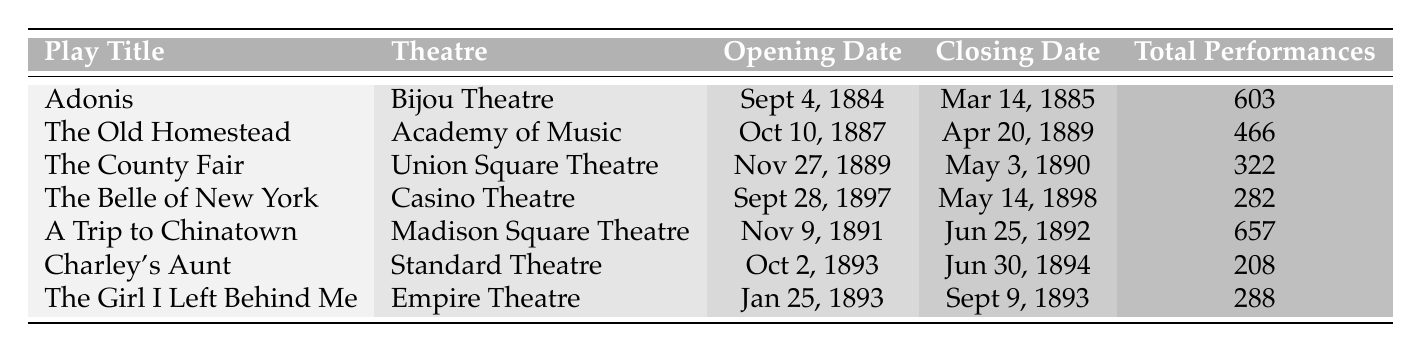What is the title of the play with the longest run in New York City between 1870 and 1900? The play with the longest run is "A Trip to Chinatown" with a total of 657 performances. This can be found by comparing the "Total Performances" column, where "A Trip to Chinatown" has the highest number.
Answer: A Trip to Chinatown Which theatre hosted "Adonis"? The table indicates that "Adonis" was hosted at the Bijou Theatre, as seen in the corresponding row under the "Theatre" column next to its title.
Answer: Bijou Theatre What is the total number of performances for "The Old Homestead"? The "Total Performances" for "The Old Homestead" is noted as 466, which can be found directly in its corresponding row in the "Total Performances" column.
Answer: 466 How many more performances did "A Trip to Chinatown" have compared to "The Girl I Left Behind Me"? "A Trip to Chinatown" had 657 performances while "The Girl I Left Behind Me" had 288. The difference is calculated as 657 - 288 = 369.
Answer: 369 Did "Charley's Aunt" run longer than "The County Fair"? "Charley's Aunt" had 208 performances, whereas "The County Fair" had 322 performances. Since 208 is less than 322, the answer is no.
Answer: No What is the average number of performances for all plays listed? First, we sum the total performances: 603 + 466 + 322 + 282 + 657 + 208 + 288 = 2826. There are 7 plays, so we calculate the average as 2826 / 7 = 403.71.
Answer: 403.71 Which play had the most performances, and what theatre was it performed in? "A Trip to Chinatown" had the highest performances at 657, performed at Madison Square Theatre. This information can be pieced together from the "Total Performances" and "Theatre" columns.
Answer: A Trip to Chinatown, Madison Square Theatre What were the opening and closing dates of "The Belle of New York"? "The Belle of New York" opened on September 28, 1897, and closed on May 14, 1898. These dates can be found directly in the respective columns for its row.
Answer: September 28, 1897, and May 14, 1898 How many theatres hosted productions that had more than 300 performances? The entries with more than 300 performances are "A Trip to Chinatown," "Adonis," "The Old Homestead," and "The County Fair," totaling 4 theatres; this can be counted by filtering the "Total Performances" column for values greater than 300.
Answer: 4 